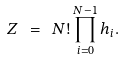<formula> <loc_0><loc_0><loc_500><loc_500>Z \ = \ N ! \prod _ { i = 0 } ^ { N - 1 } h _ { i } .</formula> 